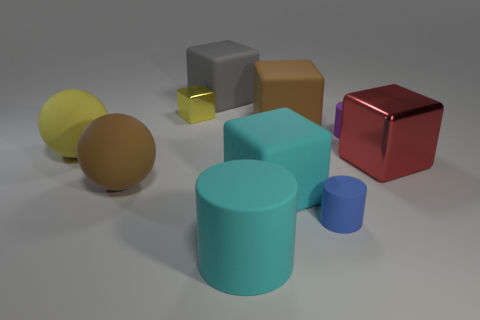Are there any other matte things that have the same shape as the big yellow matte object?
Ensure brevity in your answer.  Yes. Is the small purple thing the same shape as the tiny blue object?
Offer a terse response. Yes. What number of small things are green balls or brown rubber things?
Ensure brevity in your answer.  0. Are there more cylinders than brown spheres?
Offer a terse response. Yes. There is a gray thing that is made of the same material as the small purple cylinder; what size is it?
Offer a very short reply. Large. Does the rubber object that is to the right of the small blue matte cylinder have the same size as the shiny block in front of the yellow rubber thing?
Make the answer very short. No. How many things are rubber objects that are to the right of the tiny metal object or spheres?
Offer a terse response. 8. Is the number of small blue shiny blocks less than the number of blue rubber things?
Your answer should be very brief. Yes. The big object that is behind the large brown rubber thing on the right side of the shiny cube left of the big cyan matte cylinder is what shape?
Your answer should be compact. Cube. What shape is the rubber thing that is the same color as the big matte cylinder?
Your answer should be very brief. Cube. 